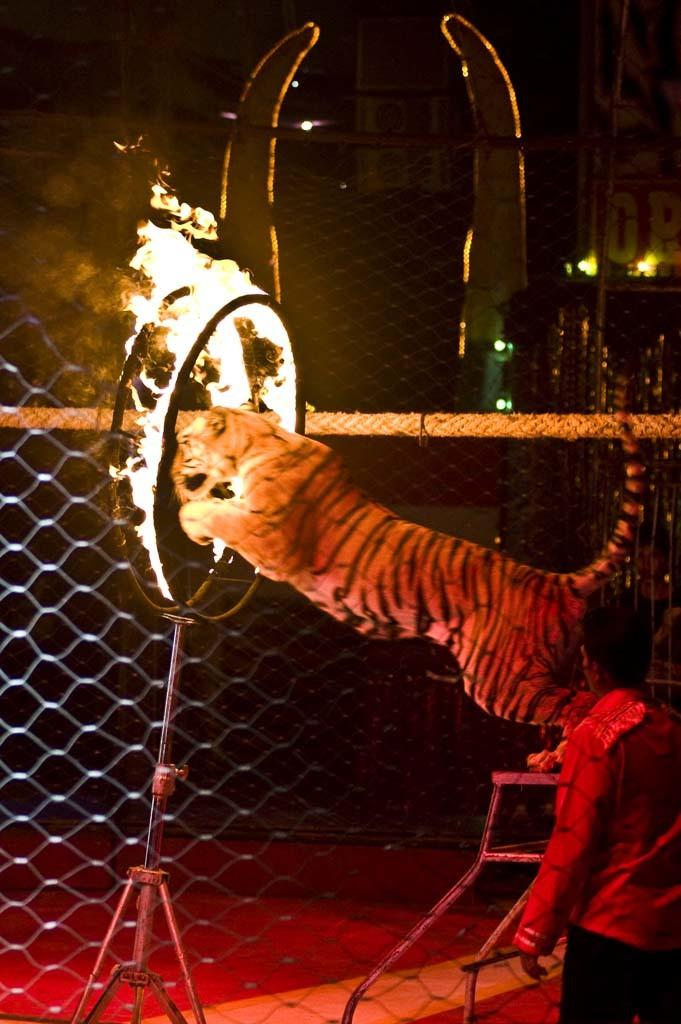What animal is in the image? There is a tiger in the image. What is the tiger doing in the image? The tiger is jumping in the image. What is the tiger jumping into? The tiger is jumping into a fire ring in the image. Can you describe the person in the image? There is a person standing on the right side of the image. What type of police activity is happening in the image? There is no police activity present in the image; it features a tiger jumping into a fire ring and a person standing nearby. 